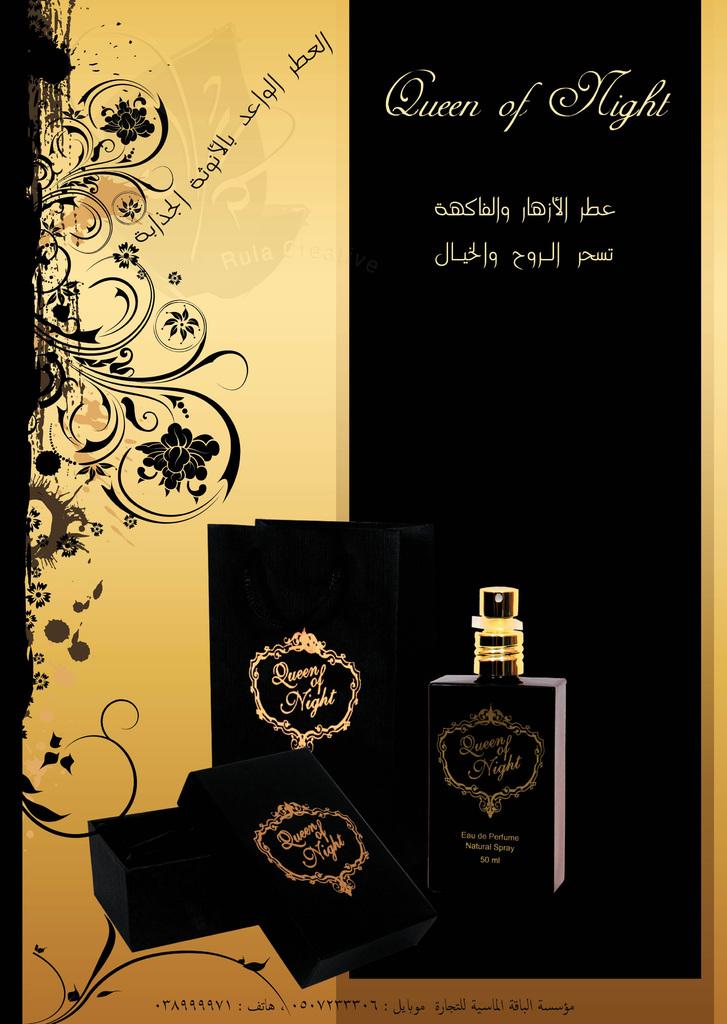What is the name of the perfume?
Your answer should be very brief. Queen of night. How many ml in this bottle of perfume?
Give a very brief answer. 50. 